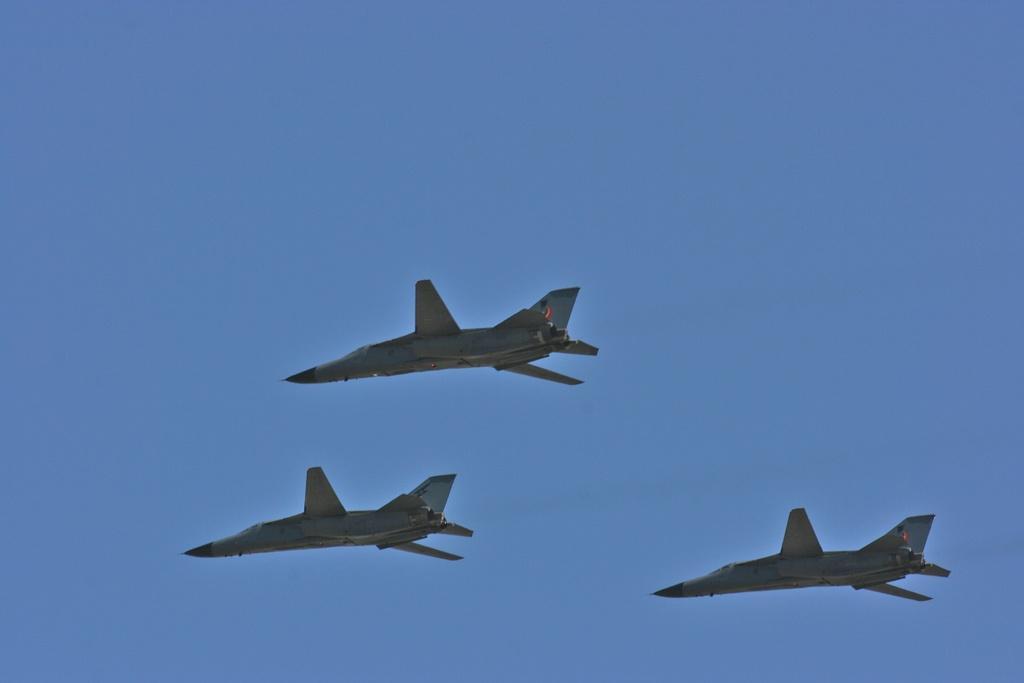In one or two sentences, can you explain what this image depicts? In this image I can see three aircraft. I can also see blue color in background. 